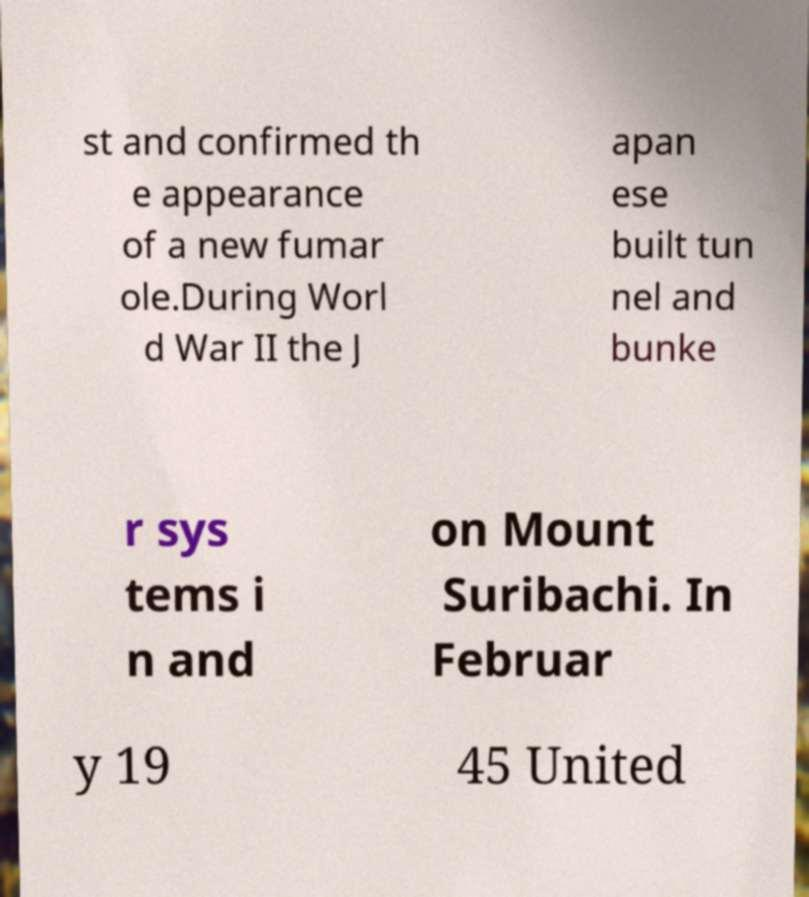Please identify and transcribe the text found in this image. st and confirmed th e appearance of a new fumar ole.During Worl d War II the J apan ese built tun nel and bunke r sys tems i n and on Mount Suribachi. In Februar y 19 45 United 